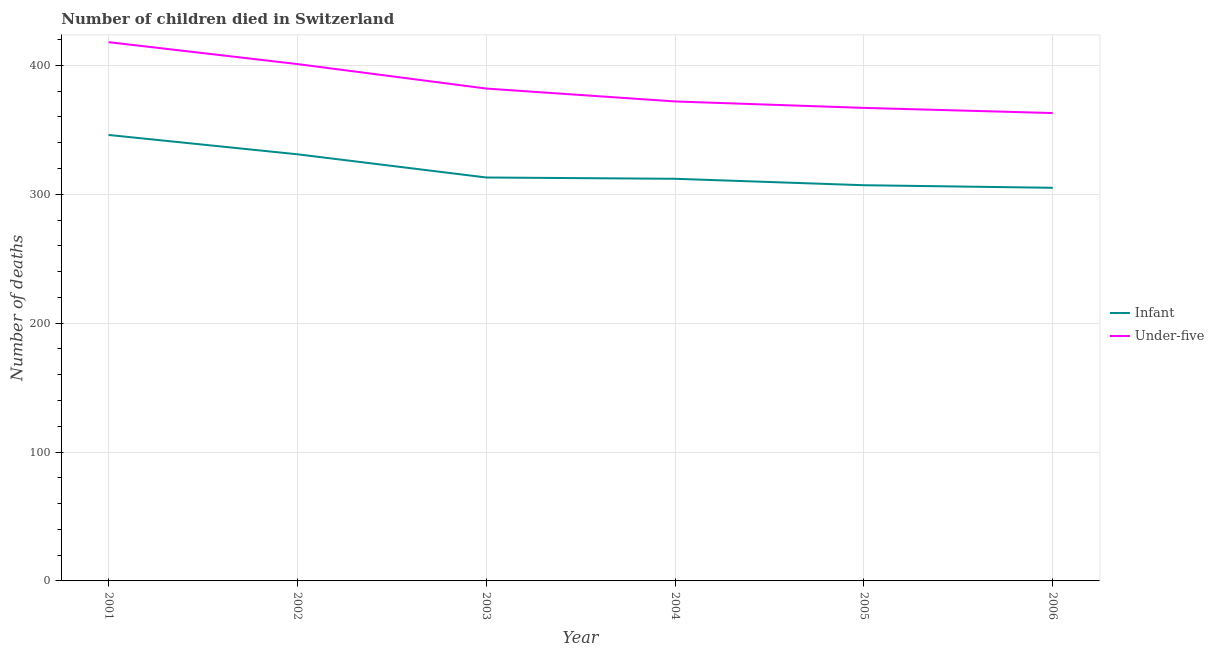Does the line corresponding to number of infant deaths intersect with the line corresponding to number of under-five deaths?
Your answer should be compact. No. What is the number of under-five deaths in 2004?
Your response must be concise. 372. Across all years, what is the maximum number of infant deaths?
Your response must be concise. 346. Across all years, what is the minimum number of under-five deaths?
Give a very brief answer. 363. In which year was the number of infant deaths maximum?
Give a very brief answer. 2001. In which year was the number of under-five deaths minimum?
Provide a short and direct response. 2006. What is the total number of infant deaths in the graph?
Give a very brief answer. 1914. What is the difference between the number of infant deaths in 2002 and that in 2005?
Provide a succinct answer. 24. What is the difference between the number of infant deaths in 2003 and the number of under-five deaths in 2001?
Your answer should be compact. -105. What is the average number of infant deaths per year?
Make the answer very short. 319. In the year 2005, what is the difference between the number of infant deaths and number of under-five deaths?
Your answer should be very brief. -60. What is the ratio of the number of infant deaths in 2004 to that in 2005?
Offer a terse response. 1.02. What is the difference between the highest and the lowest number of infant deaths?
Offer a very short reply. 41. Is the sum of the number of under-five deaths in 2002 and 2005 greater than the maximum number of infant deaths across all years?
Provide a short and direct response. Yes. Is the number of under-five deaths strictly greater than the number of infant deaths over the years?
Your response must be concise. Yes. How many lines are there?
Provide a succinct answer. 2. What is the difference between two consecutive major ticks on the Y-axis?
Provide a short and direct response. 100. Does the graph contain grids?
Make the answer very short. Yes. How are the legend labels stacked?
Your answer should be very brief. Vertical. What is the title of the graph?
Your response must be concise. Number of children died in Switzerland. Does "Non-solid fuel" appear as one of the legend labels in the graph?
Provide a succinct answer. No. What is the label or title of the X-axis?
Give a very brief answer. Year. What is the label or title of the Y-axis?
Give a very brief answer. Number of deaths. What is the Number of deaths of Infant in 2001?
Your answer should be compact. 346. What is the Number of deaths in Under-five in 2001?
Give a very brief answer. 418. What is the Number of deaths of Infant in 2002?
Keep it short and to the point. 331. What is the Number of deaths in Under-five in 2002?
Your answer should be very brief. 401. What is the Number of deaths of Infant in 2003?
Keep it short and to the point. 313. What is the Number of deaths of Under-five in 2003?
Make the answer very short. 382. What is the Number of deaths of Infant in 2004?
Offer a terse response. 312. What is the Number of deaths in Under-five in 2004?
Make the answer very short. 372. What is the Number of deaths of Infant in 2005?
Keep it short and to the point. 307. What is the Number of deaths in Under-five in 2005?
Your response must be concise. 367. What is the Number of deaths of Infant in 2006?
Your answer should be compact. 305. What is the Number of deaths in Under-five in 2006?
Your response must be concise. 363. Across all years, what is the maximum Number of deaths of Infant?
Your answer should be very brief. 346. Across all years, what is the maximum Number of deaths in Under-five?
Your response must be concise. 418. Across all years, what is the minimum Number of deaths of Infant?
Your answer should be compact. 305. Across all years, what is the minimum Number of deaths in Under-five?
Your response must be concise. 363. What is the total Number of deaths in Infant in the graph?
Keep it short and to the point. 1914. What is the total Number of deaths of Under-five in the graph?
Offer a very short reply. 2303. What is the difference between the Number of deaths of Infant in 2001 and that in 2002?
Provide a succinct answer. 15. What is the difference between the Number of deaths in Under-five in 2001 and that in 2004?
Your answer should be compact. 46. What is the difference between the Number of deaths of Under-five in 2001 and that in 2005?
Your response must be concise. 51. What is the difference between the Number of deaths in Infant in 2001 and that in 2006?
Ensure brevity in your answer.  41. What is the difference between the Number of deaths in Under-five in 2001 and that in 2006?
Your answer should be very brief. 55. What is the difference between the Number of deaths in Infant in 2002 and that in 2005?
Your answer should be compact. 24. What is the difference between the Number of deaths of Under-five in 2002 and that in 2005?
Your response must be concise. 34. What is the difference between the Number of deaths of Under-five in 2003 and that in 2004?
Ensure brevity in your answer.  10. What is the difference between the Number of deaths of Infant in 2003 and that in 2005?
Offer a terse response. 6. What is the difference between the Number of deaths of Under-five in 2004 and that in 2005?
Keep it short and to the point. 5. What is the difference between the Number of deaths of Infant in 2004 and that in 2006?
Your response must be concise. 7. What is the difference between the Number of deaths in Infant in 2005 and that in 2006?
Offer a terse response. 2. What is the difference between the Number of deaths in Infant in 2001 and the Number of deaths in Under-five in 2002?
Ensure brevity in your answer.  -55. What is the difference between the Number of deaths in Infant in 2001 and the Number of deaths in Under-five in 2003?
Make the answer very short. -36. What is the difference between the Number of deaths of Infant in 2001 and the Number of deaths of Under-five in 2004?
Keep it short and to the point. -26. What is the difference between the Number of deaths in Infant in 2001 and the Number of deaths in Under-five in 2006?
Keep it short and to the point. -17. What is the difference between the Number of deaths of Infant in 2002 and the Number of deaths of Under-five in 2003?
Give a very brief answer. -51. What is the difference between the Number of deaths in Infant in 2002 and the Number of deaths in Under-five in 2004?
Ensure brevity in your answer.  -41. What is the difference between the Number of deaths in Infant in 2002 and the Number of deaths in Under-five in 2005?
Offer a very short reply. -36. What is the difference between the Number of deaths in Infant in 2002 and the Number of deaths in Under-five in 2006?
Give a very brief answer. -32. What is the difference between the Number of deaths of Infant in 2003 and the Number of deaths of Under-five in 2004?
Provide a short and direct response. -59. What is the difference between the Number of deaths in Infant in 2003 and the Number of deaths in Under-five in 2005?
Give a very brief answer. -54. What is the difference between the Number of deaths of Infant in 2004 and the Number of deaths of Under-five in 2005?
Provide a succinct answer. -55. What is the difference between the Number of deaths in Infant in 2004 and the Number of deaths in Under-five in 2006?
Offer a terse response. -51. What is the difference between the Number of deaths of Infant in 2005 and the Number of deaths of Under-five in 2006?
Offer a terse response. -56. What is the average Number of deaths in Infant per year?
Your answer should be very brief. 319. What is the average Number of deaths of Under-five per year?
Give a very brief answer. 383.83. In the year 2001, what is the difference between the Number of deaths of Infant and Number of deaths of Under-five?
Provide a succinct answer. -72. In the year 2002, what is the difference between the Number of deaths in Infant and Number of deaths in Under-five?
Keep it short and to the point. -70. In the year 2003, what is the difference between the Number of deaths of Infant and Number of deaths of Under-five?
Offer a very short reply. -69. In the year 2004, what is the difference between the Number of deaths of Infant and Number of deaths of Under-five?
Your answer should be very brief. -60. In the year 2005, what is the difference between the Number of deaths of Infant and Number of deaths of Under-five?
Keep it short and to the point. -60. In the year 2006, what is the difference between the Number of deaths of Infant and Number of deaths of Under-five?
Keep it short and to the point. -58. What is the ratio of the Number of deaths of Infant in 2001 to that in 2002?
Your answer should be very brief. 1.05. What is the ratio of the Number of deaths in Under-five in 2001 to that in 2002?
Your answer should be very brief. 1.04. What is the ratio of the Number of deaths of Infant in 2001 to that in 2003?
Your answer should be very brief. 1.11. What is the ratio of the Number of deaths in Under-five in 2001 to that in 2003?
Your answer should be compact. 1.09. What is the ratio of the Number of deaths of Infant in 2001 to that in 2004?
Your answer should be very brief. 1.11. What is the ratio of the Number of deaths of Under-five in 2001 to that in 2004?
Your answer should be very brief. 1.12. What is the ratio of the Number of deaths of Infant in 2001 to that in 2005?
Make the answer very short. 1.13. What is the ratio of the Number of deaths in Under-five in 2001 to that in 2005?
Provide a succinct answer. 1.14. What is the ratio of the Number of deaths of Infant in 2001 to that in 2006?
Provide a succinct answer. 1.13. What is the ratio of the Number of deaths of Under-five in 2001 to that in 2006?
Provide a short and direct response. 1.15. What is the ratio of the Number of deaths of Infant in 2002 to that in 2003?
Provide a short and direct response. 1.06. What is the ratio of the Number of deaths in Under-five in 2002 to that in 2003?
Keep it short and to the point. 1.05. What is the ratio of the Number of deaths of Infant in 2002 to that in 2004?
Offer a terse response. 1.06. What is the ratio of the Number of deaths in Under-five in 2002 to that in 2004?
Ensure brevity in your answer.  1.08. What is the ratio of the Number of deaths in Infant in 2002 to that in 2005?
Provide a succinct answer. 1.08. What is the ratio of the Number of deaths in Under-five in 2002 to that in 2005?
Your answer should be very brief. 1.09. What is the ratio of the Number of deaths of Infant in 2002 to that in 2006?
Keep it short and to the point. 1.09. What is the ratio of the Number of deaths of Under-five in 2002 to that in 2006?
Keep it short and to the point. 1.1. What is the ratio of the Number of deaths in Under-five in 2003 to that in 2004?
Give a very brief answer. 1.03. What is the ratio of the Number of deaths in Infant in 2003 to that in 2005?
Give a very brief answer. 1.02. What is the ratio of the Number of deaths in Under-five in 2003 to that in 2005?
Give a very brief answer. 1.04. What is the ratio of the Number of deaths in Infant in 2003 to that in 2006?
Your answer should be compact. 1.03. What is the ratio of the Number of deaths of Under-five in 2003 to that in 2006?
Your answer should be very brief. 1.05. What is the ratio of the Number of deaths in Infant in 2004 to that in 2005?
Offer a terse response. 1.02. What is the ratio of the Number of deaths in Under-five in 2004 to that in 2005?
Provide a succinct answer. 1.01. What is the ratio of the Number of deaths in Infant in 2004 to that in 2006?
Make the answer very short. 1.02. What is the ratio of the Number of deaths of Under-five in 2004 to that in 2006?
Ensure brevity in your answer.  1.02. What is the ratio of the Number of deaths of Infant in 2005 to that in 2006?
Keep it short and to the point. 1.01. What is the ratio of the Number of deaths in Under-five in 2005 to that in 2006?
Keep it short and to the point. 1.01. What is the difference between the highest and the second highest Number of deaths of Under-five?
Keep it short and to the point. 17. What is the difference between the highest and the lowest Number of deaths of Under-five?
Provide a succinct answer. 55. 